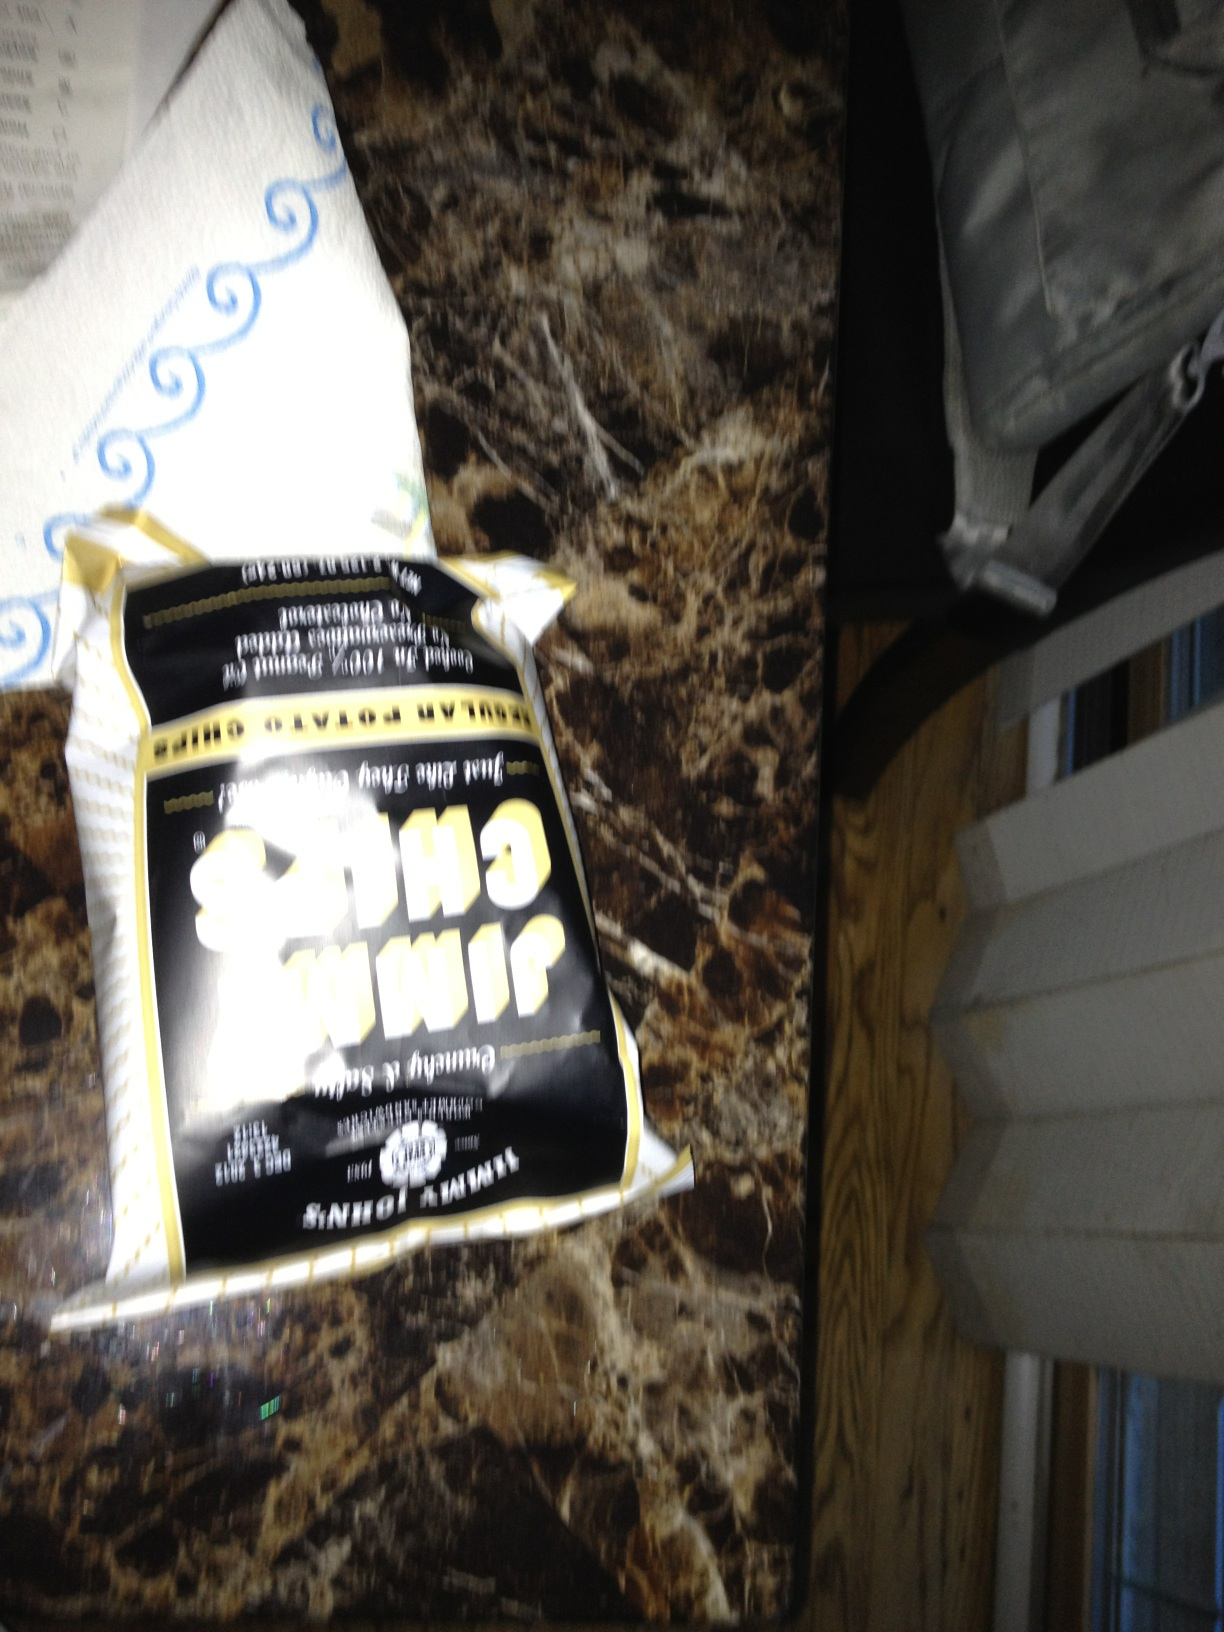Can you tell me more about the setting where this photo was taken? The image appears to be taken indoors with artificial lighting, likely on a kitchen countertop, as indicated by what seems to be a paper towel roll and a stone-patterned surface which is commonly used in such spaces. The presence of the chips suggests that someone might have been enjoying a snack here. 